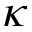Convert formula to latex. <formula><loc_0><loc_0><loc_500><loc_500>\kappa</formula> 